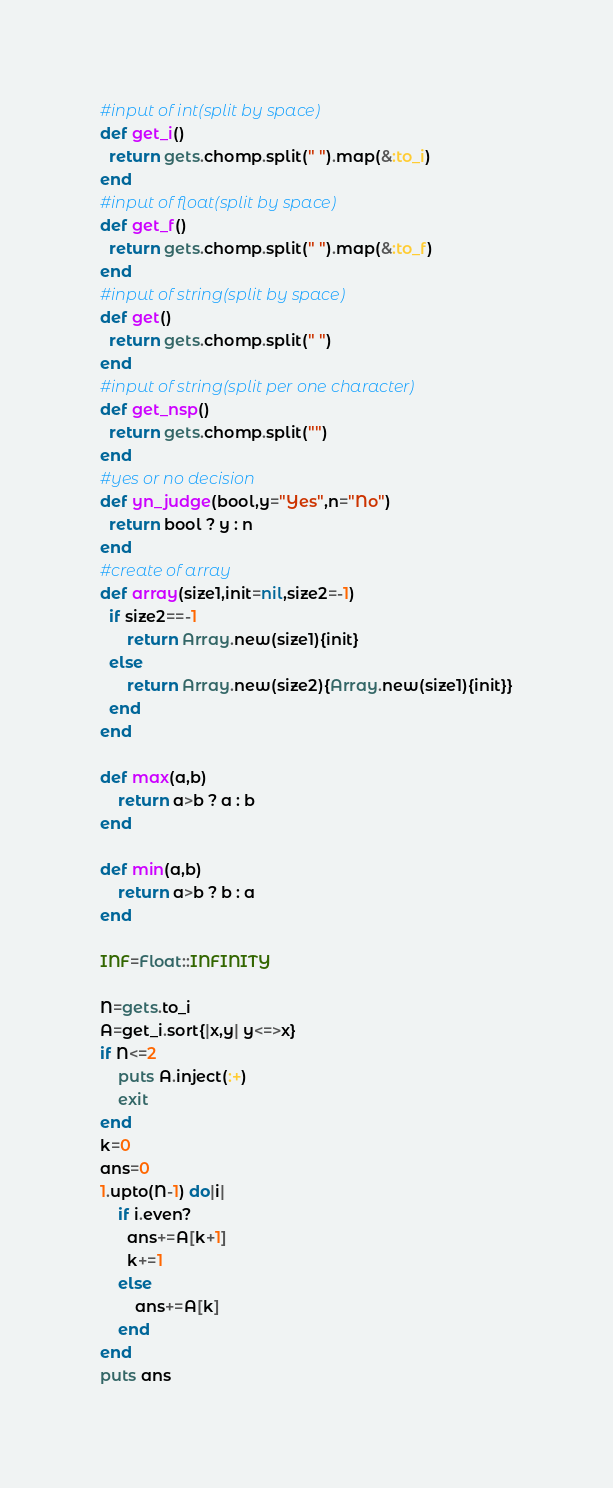<code> <loc_0><loc_0><loc_500><loc_500><_Ruby_>#input of int(split by space)
def get_i()
  return gets.chomp.split(" ").map(&:to_i)
end
#input of float(split by space)
def get_f()
  return gets.chomp.split(" ").map(&:to_f)
end
#input of string(split by space)
def get()
  return gets.chomp.split(" ")
end
#input of string(split per one character)
def get_nsp()
  return gets.chomp.split("")
end
#yes or no decision
def yn_judge(bool,y="Yes",n="No")
  return bool ? y : n 
end
#create of array
def array(size1,init=nil,size2=-1)
  if size2==-1
      return Array.new(size1){init}
  else
      return Array.new(size2){Array.new(size1){init}}
  end
end

def max(a,b)
    return a>b ? a : b
end

def min(a,b)
    return a>b ? b : a
end

INF=Float::INFINITY

N=gets.to_i
A=get_i.sort{|x,y| y<=>x}
if N<=2
    puts A.inject(:+)
    exit
end
k=0
ans=0
1.upto(N-1) do|i|
    if i.even?
      ans+=A[k+1]
      k+=1
    else
        ans+=A[k]
    end
end
puts ans</code> 